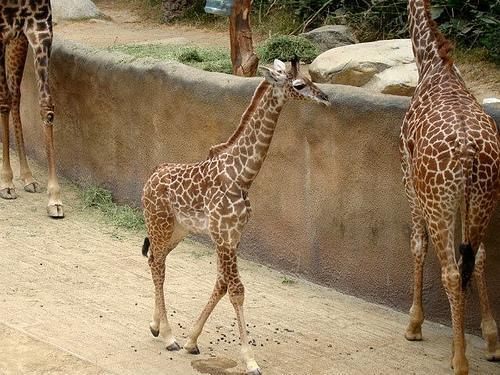How many animals are standing near the rock wall?
Give a very brief answer. 3. How many adults animals do you see?
Give a very brief answer. 2. How many giraffes are there?
Give a very brief answer. 3. 